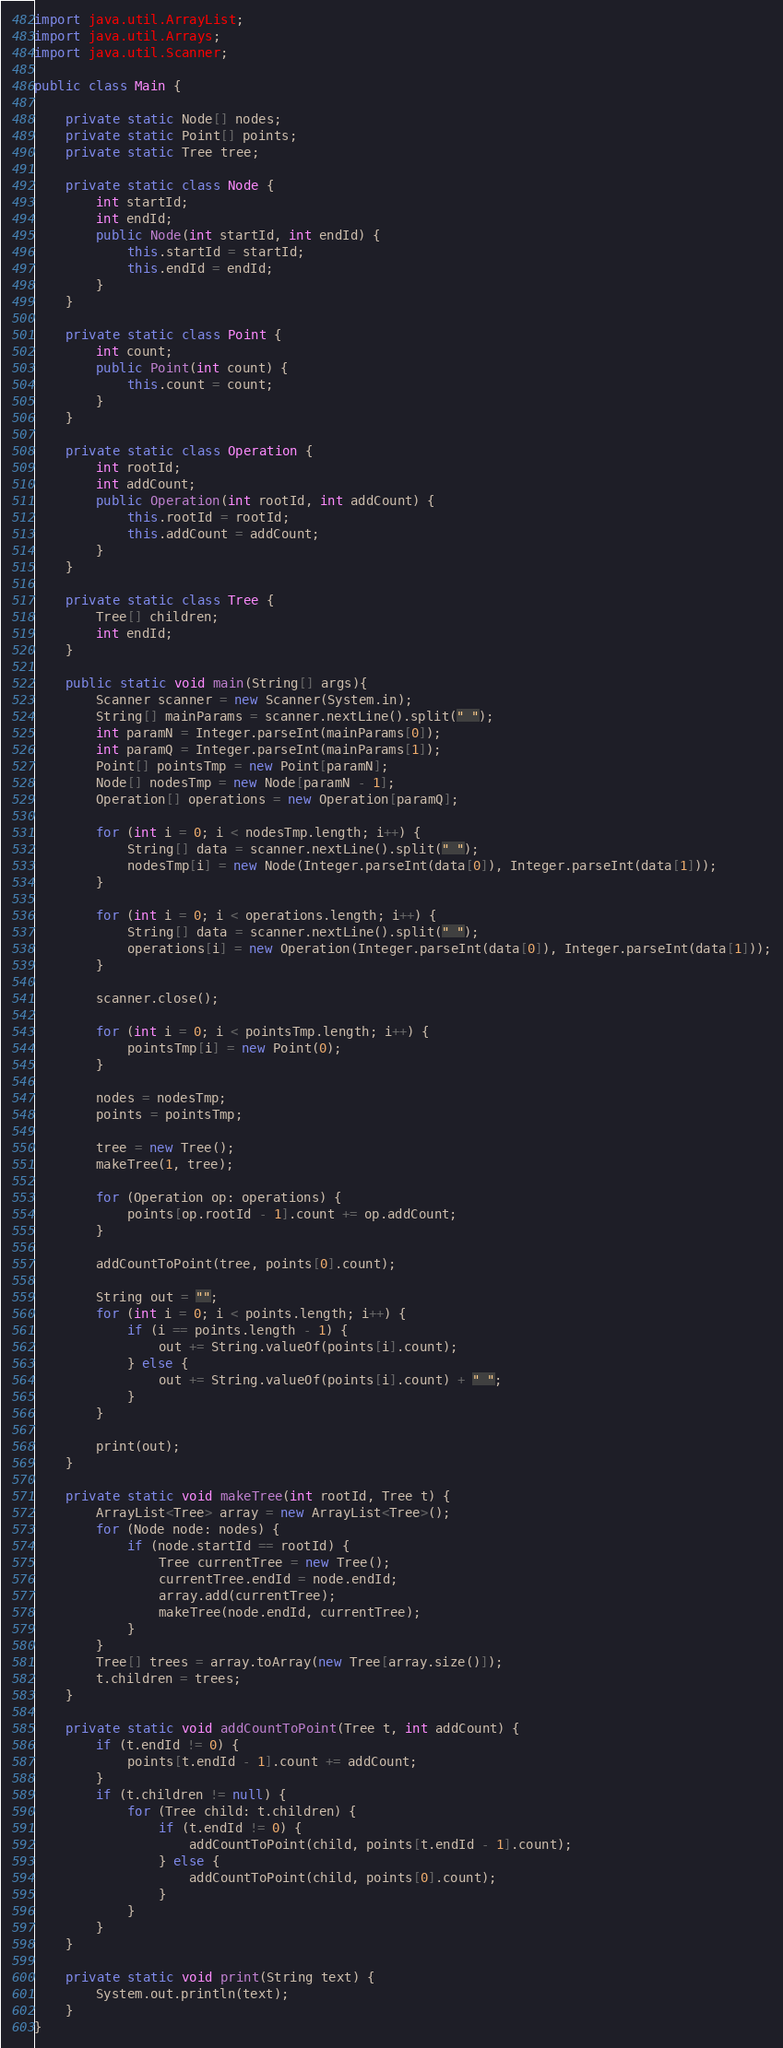<code> <loc_0><loc_0><loc_500><loc_500><_Java_>import java.util.ArrayList;
import java.util.Arrays;
import java.util.Scanner;

public class Main {

    private static Node[] nodes;
    private static Point[] points;
    private static Tree tree;

    private static class Node {
        int startId;
        int endId;
        public Node(int startId, int endId) {
            this.startId = startId;
            this.endId = endId;
        }
    }

    private static class Point {
        int count;
        public Point(int count) {
            this.count = count;
        }
    }

    private static class Operation {
        int rootId;
        int addCount;
        public Operation(int rootId, int addCount) {
            this.rootId = rootId;
            this.addCount = addCount;
        }
    }

    private static class Tree {
        Tree[] children;
        int endId;
    }

    public static void main(String[] args){
        Scanner scanner = new Scanner(System.in);
        String[] mainParams = scanner.nextLine().split(" ");
        int paramN = Integer.parseInt(mainParams[0]);
        int paramQ = Integer.parseInt(mainParams[1]);
        Point[] pointsTmp = new Point[paramN];
        Node[] nodesTmp = new Node[paramN - 1];
        Operation[] operations = new Operation[paramQ];

        for (int i = 0; i < nodesTmp.length; i++) {
            String[] data = scanner.nextLine().split(" ");
            nodesTmp[i] = new Node(Integer.parseInt(data[0]), Integer.parseInt(data[1]));
        }

        for (int i = 0; i < operations.length; i++) {
            String[] data = scanner.nextLine().split(" ");
            operations[i] = new Operation(Integer.parseInt(data[0]), Integer.parseInt(data[1]));
        }

        scanner.close();

        for (int i = 0; i < pointsTmp.length; i++) {
            pointsTmp[i] = new Point(0);
        }

        nodes = nodesTmp;
        points = pointsTmp;

        tree = new Tree();
        makeTree(1, tree);

        for (Operation op: operations) {
            points[op.rootId - 1].count += op.addCount;
        }

        addCountToPoint(tree, points[0].count);

        String out = "";
        for (int i = 0; i < points.length; i++) {
            if (i == points.length - 1) {
                out += String.valueOf(points[i].count);
            } else {
                out += String.valueOf(points[i].count) + " ";
            }
        }

        print(out);
    }

    private static void makeTree(int rootId, Tree t) {
        ArrayList<Tree> array = new ArrayList<Tree>();
        for (Node node: nodes) {
            if (node.startId == rootId) {
                Tree currentTree = new Tree();
                currentTree.endId = node.endId;
                array.add(currentTree);
                makeTree(node.endId, currentTree);
            }
        }
        Tree[] trees = array.toArray(new Tree[array.size()]);
        t.children = trees;
    }

    private static void addCountToPoint(Tree t, int addCount) {
        if (t.endId != 0) {
            points[t.endId - 1].count += addCount;
        }
        if (t.children != null) {
            for (Tree child: t.children) {
                if (t.endId != 0) {
                    addCountToPoint(child, points[t.endId - 1].count);
                } else {
                    addCountToPoint(child, points[0].count);
                }
            }
        }
    }

    private static void print(String text) {
        System.out.println(text);
    }
}</code> 